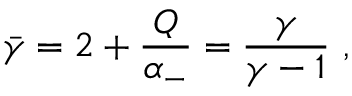<formula> <loc_0><loc_0><loc_500><loc_500>\bar { \gamma } = 2 + { \frac { Q } { \alpha _ { - } } } = { \frac { \gamma } { \gamma - 1 } } \ ,</formula> 